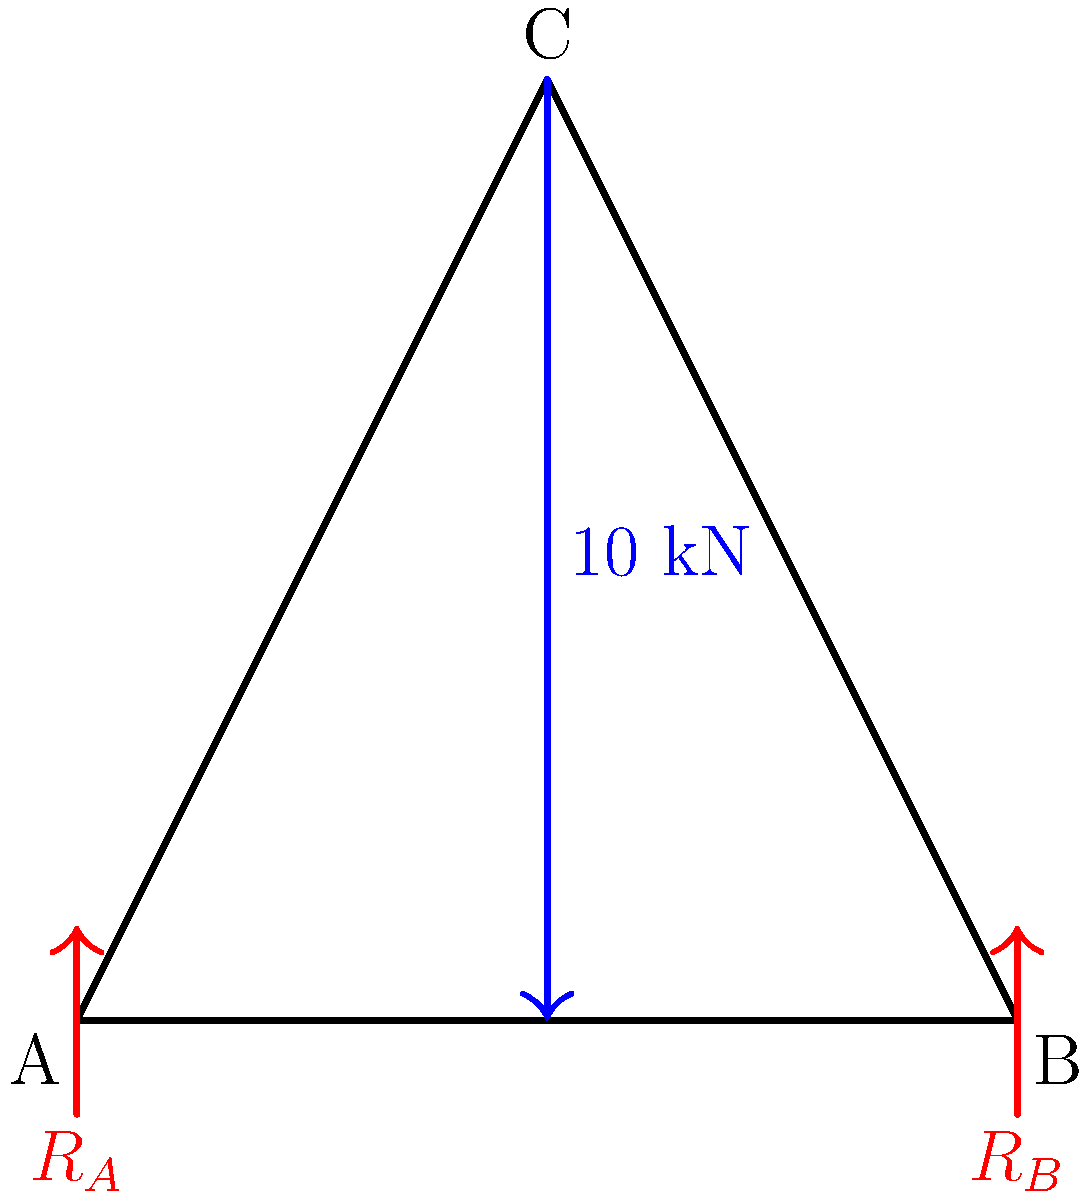Given the truss diagram above, where a 10 kN vertical load is applied at point C, calculate the reaction forces $R_A$ and $R_B$ at the supports A and B. To solve this problem, we'll use the method of joints and the equations of equilibrium. Let's follow these steps:

1) First, we need to establish the equations of equilibrium for the entire truss:

   $$\sum F_x = 0$$ (no horizontal forces)
   $$\sum F_y = R_A + R_B - 10 = 0$$ (vertical equilibrium)
   $$\sum M_A = 10 \cdot 50 - R_B \cdot 100 = 0$$ (moment equilibrium about point A)

2) From the moment equation:
   $$500 - 100R_B = 0$$
   $$R_B = 5 \text{ kN}$$

3) Substituting this into the vertical equilibrium equation:
   $$R_A + 5 - 10 = 0$$
   $$R_A = 5 \text{ kN}$$

4) We can verify our results by checking that the sum of the reactions equals the applied load:
   $$R_A + R_B = 5 + 5 = 10 \text{ kN}$$

Therefore, the reaction forces are $R_A = 5 \text{ kN}$ and $R_B = 5 \text{ kN}$.
Answer: $R_A = 5 \text{ kN}, R_B = 5 \text{ kN}$ 